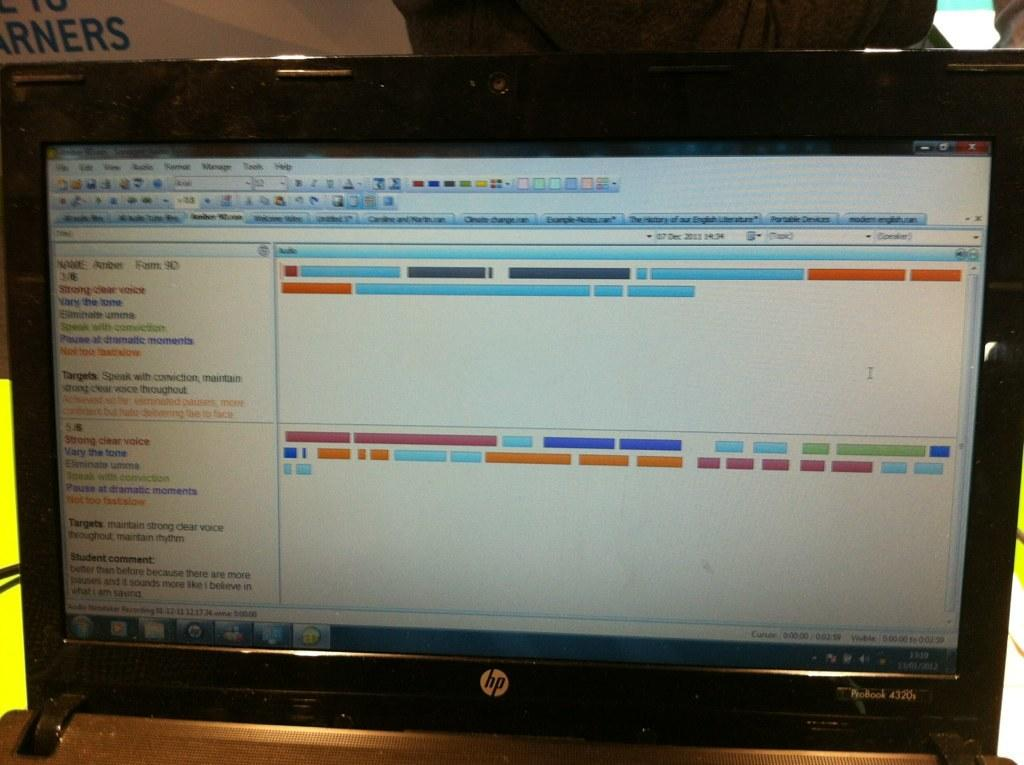<image>
Offer a succinct explanation of the picture presented. an HP computer with open monitor showing colorful shapes 